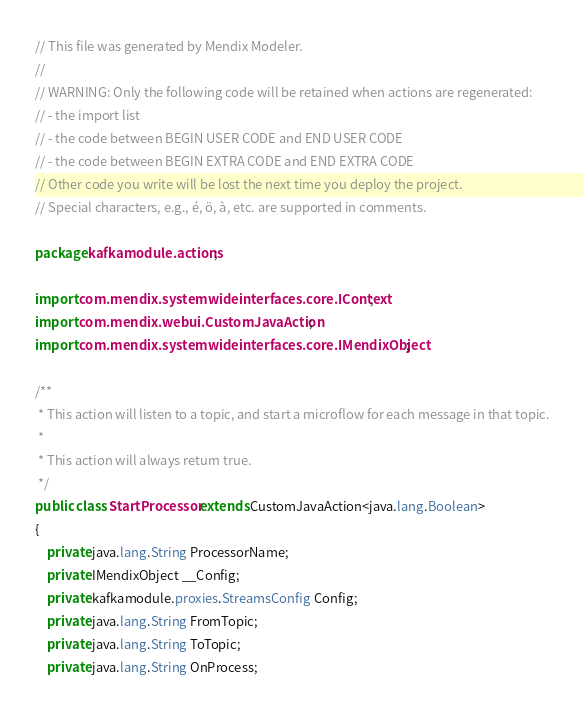<code> <loc_0><loc_0><loc_500><loc_500><_Java_>// This file was generated by Mendix Modeler.
//
// WARNING: Only the following code will be retained when actions are regenerated:
// - the import list
// - the code between BEGIN USER CODE and END USER CODE
// - the code between BEGIN EXTRA CODE and END EXTRA CODE
// Other code you write will be lost the next time you deploy the project.
// Special characters, e.g., é, ö, à, etc. are supported in comments.

package kafkamodule.actions;

import com.mendix.systemwideinterfaces.core.IContext;
import com.mendix.webui.CustomJavaAction;
import com.mendix.systemwideinterfaces.core.IMendixObject;

/**
 * This action will listen to a topic, and start a microflow for each message in that topic.
 * 
 * This action will always return true.
 */
public class StartProcessor extends CustomJavaAction<java.lang.Boolean>
{
	private java.lang.String ProcessorName;
	private IMendixObject __Config;
	private kafkamodule.proxies.StreamsConfig Config;
	private java.lang.String FromTopic;
	private java.lang.String ToTopic;
	private java.lang.String OnProcess;</code> 